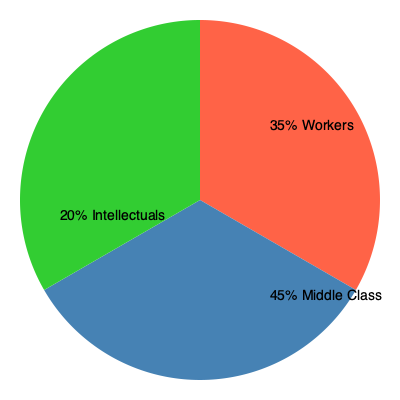Analyzing the pie chart depicting the demographic composition of Austrian Social Democratic Party supporters, what percentage of the party's base is comprised of workers, and how might this align with Karl Wöllert's vision for the party? To answer this question, we need to follow these steps:

1. Examine the pie chart carefully:
   - The chart shows three segments representing different demographic groups within the Austrian Social Democratic Party.
   - Each segment is labeled with a percentage and a group name.

2. Identify the segment representing workers:
   - The red segment at the top of the chart is labeled "35% Workers".

3. Consider Karl Wöllert's vision:
   - Karl Wöllert was a prominent figure in the Austrian Social Democratic Party.
   - He likely emphasized the importance of working-class representation in the party.

4. Analyze the alignment:
   - The 35% share for workers is significant, forming over a third of the party's support base.
   - This substantial representation aligns with the traditional social democratic focus on workers' rights and interests.
   - However, it's not a majority, which might indicate a shift towards a broader coalition including middle-class and intellectual supporters.

5. Reflect on the party's evolution:
   - The chart shows a diverse support base, with the middle class forming the largest group at 45%.
   - This distribution suggests the party has expanded its appeal beyond its working-class roots, which may or may not align with Wöllert's original vision, depending on his specific ideas about party composition.
Answer: 35%; aligns partially, showing significant worker representation but also a broader coalition. 